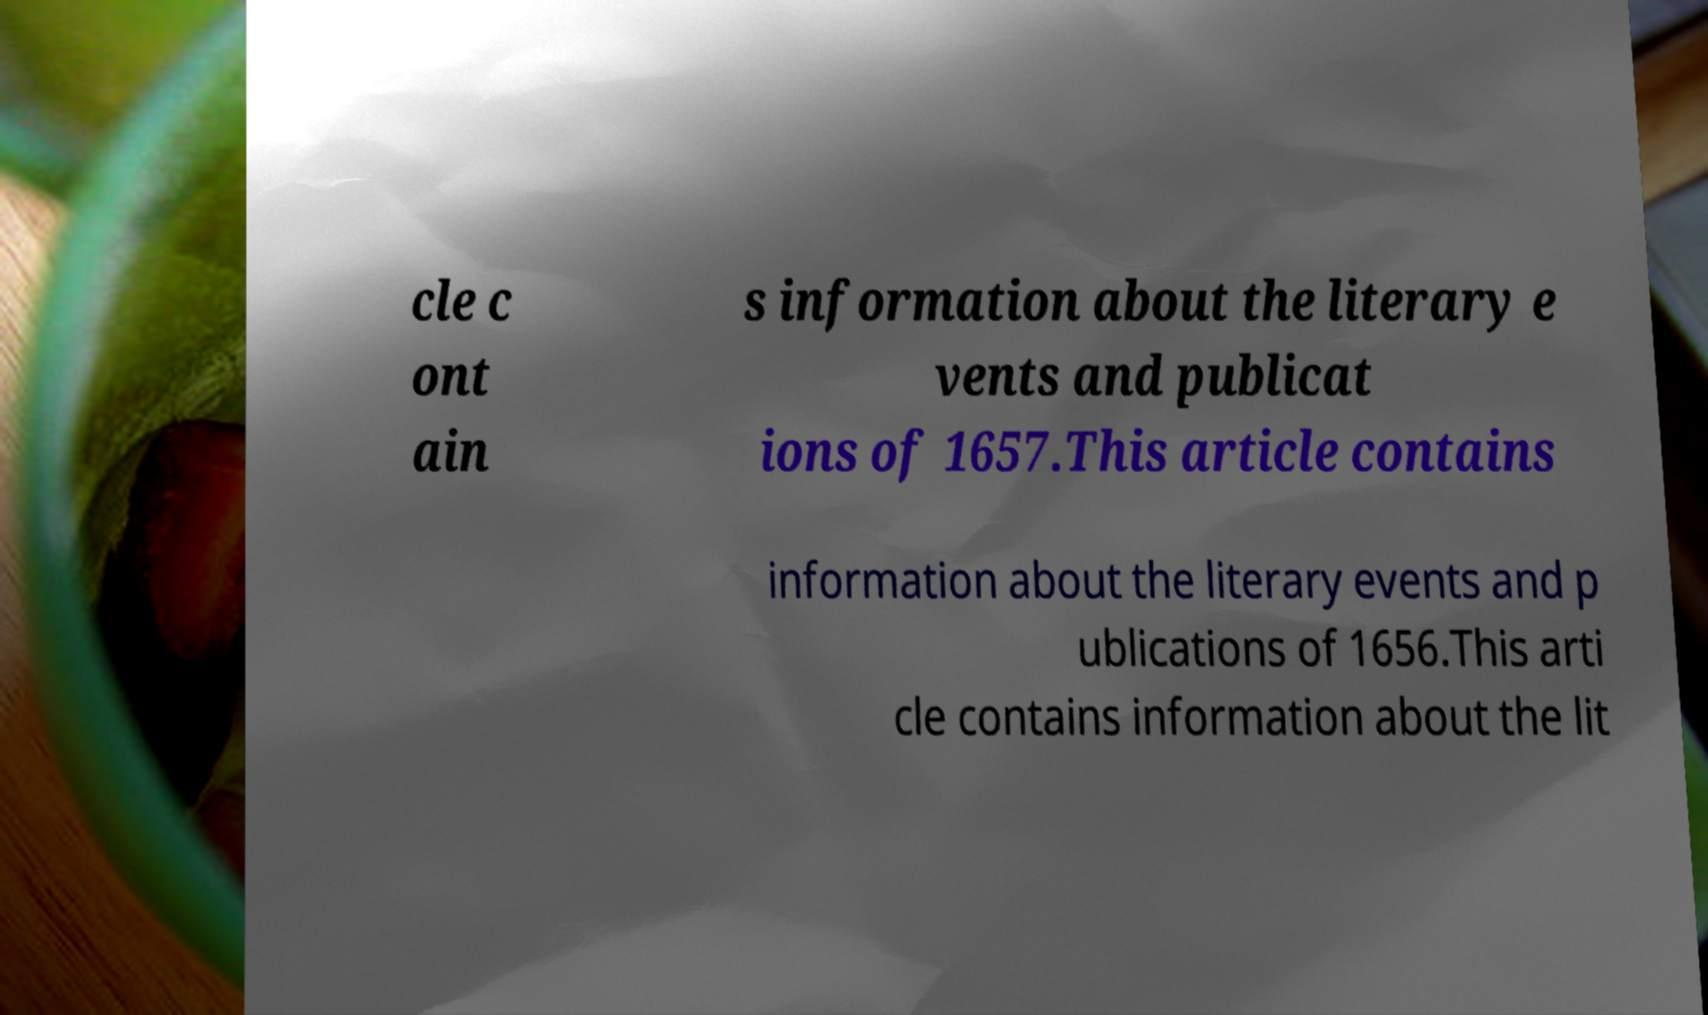I need the written content from this picture converted into text. Can you do that? cle c ont ain s information about the literary e vents and publicat ions of 1657.This article contains information about the literary events and p ublications of 1656.This arti cle contains information about the lit 